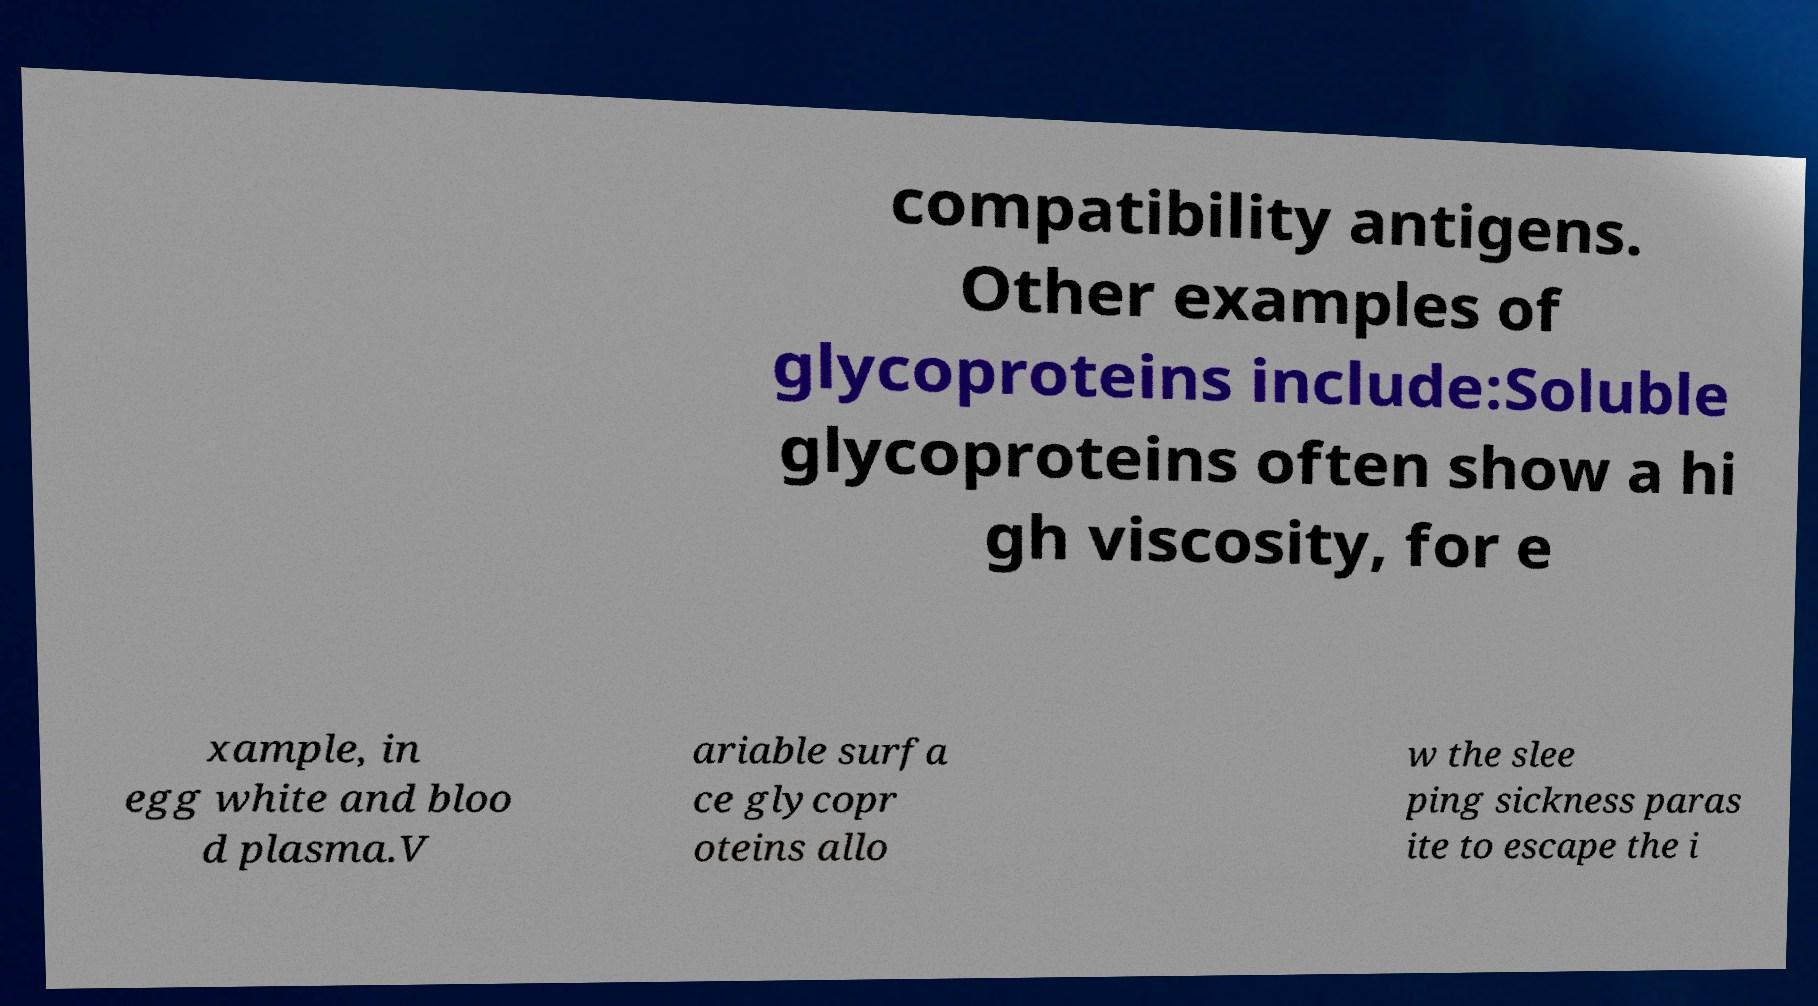What messages or text are displayed in this image? I need them in a readable, typed format. compatibility antigens. Other examples of glycoproteins include:Soluble glycoproteins often show a hi gh viscosity, for e xample, in egg white and bloo d plasma.V ariable surfa ce glycopr oteins allo w the slee ping sickness paras ite to escape the i 